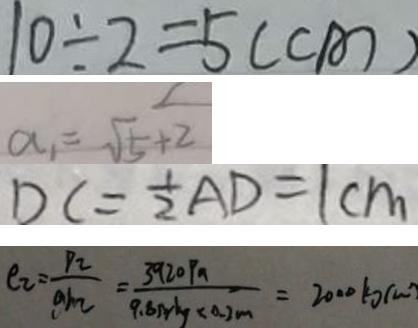<formula> <loc_0><loc_0><loc_500><loc_500>1 0 \div 2 = 5 ( c m ) 
 a _ { 1 } = \sqrt { 5 } + 2 
 D C = \frac { 1 } { 2 } A D = 1 c m 
 \rho _ { 2 } = \frac { p _ { 2 } } { g h _ { 2 } } = \frac { 3 9 2 0 P a } { 9 . 8 N / k g \times 0 . 2 m } = 2 0 0 0 k g / m</formula> 